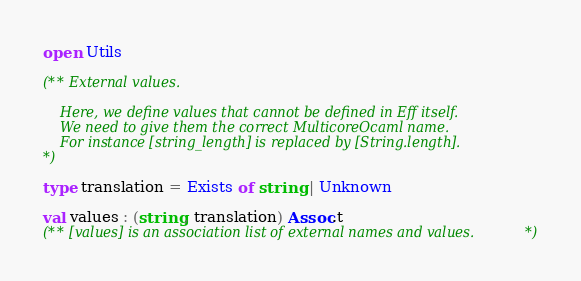Convert code to text. <code><loc_0><loc_0><loc_500><loc_500><_OCaml_>open Utils

(** External values.

    Here, we define values that cannot be defined in Eff itself.
    We need to give them the correct MulticoreOcaml name.
    For instance [string_length] is replaced by [String.length].
*)

type translation = Exists of string | Unknown

val values : (string, translation) Assoc.t
(** [values] is an association list of external names and values. *)
</code> 